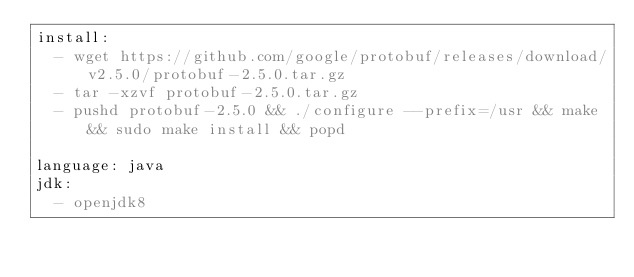<code> <loc_0><loc_0><loc_500><loc_500><_YAML_>install:
  - wget https://github.com/google/protobuf/releases/download/v2.5.0/protobuf-2.5.0.tar.gz
  - tar -xzvf protobuf-2.5.0.tar.gz
  - pushd protobuf-2.5.0 && ./configure --prefix=/usr && make && sudo make install && popd

language: java
jdk:
  - openjdk8
</code> 